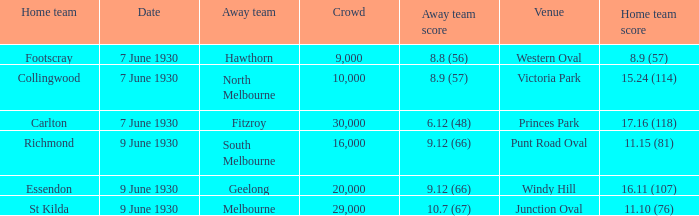12 (66) at windy hill? Geelong. 